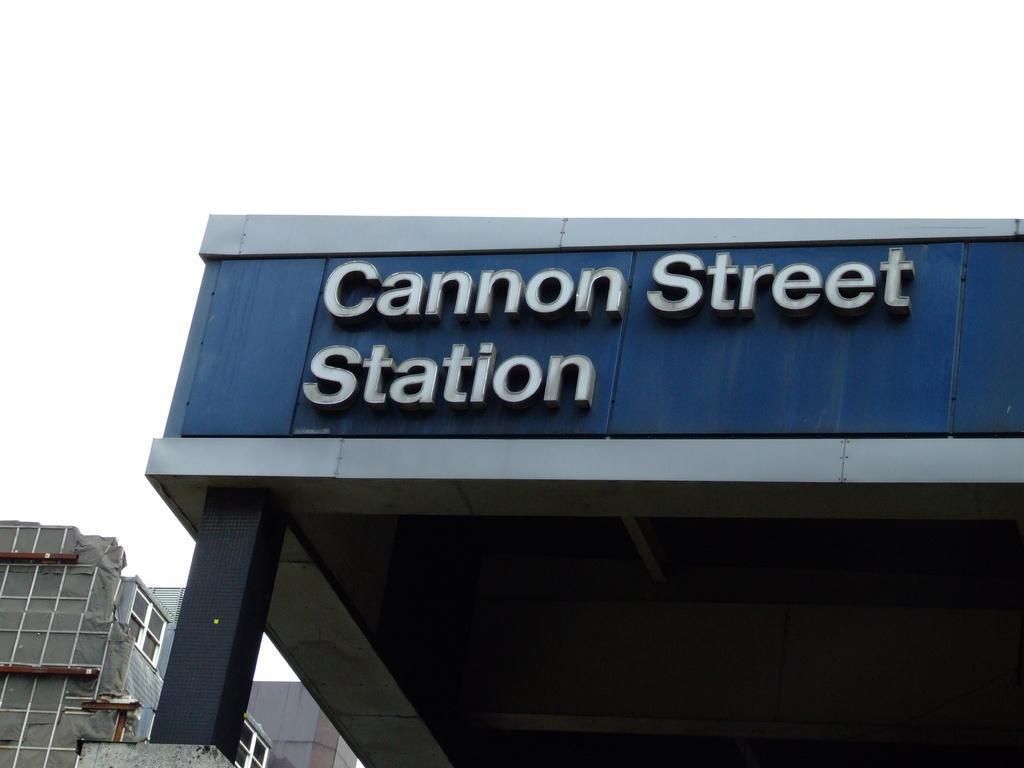Can you describe this image briefly? In this image we can see buildings and sky. 